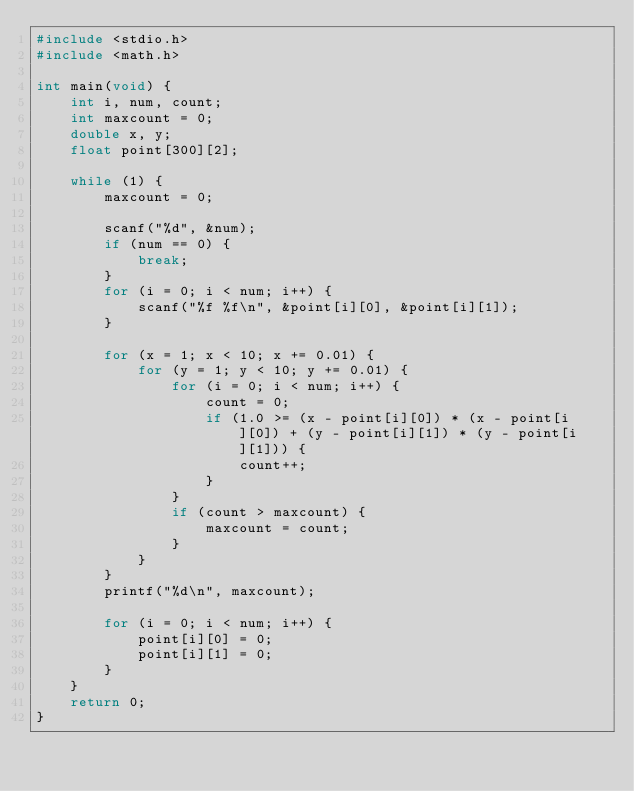Convert code to text. <code><loc_0><loc_0><loc_500><loc_500><_C_>#include <stdio.h>
#include <math.h>

int main(void) {
	int i, num, count;
	int maxcount = 0;
	double x, y;
	float point[300][2];

	while (1) {
		maxcount = 0;

		scanf("%d", &num);
		if (num == 0) {
			break;
		}
		for (i = 0; i < num; i++) {
			scanf("%f %f\n", &point[i][0], &point[i][1]);
		}

		for (x = 1; x < 10; x += 0.01) {
			for (y = 1; y < 10; y += 0.01) {
				for (i = 0; i < num; i++) {
					count = 0;
					if (1.0 >= (x - point[i][0]) * (x - point[i][0]) + (y - point[i][1]) * (y - point[i][1])) {
						count++;
					}
				}
				if (count > maxcount) {
					maxcount = count;
				}
			}
		}
		printf("%d\n", maxcount);

		for (i = 0; i < num; i++) {
			point[i][0] = 0;
			point[i][1] = 0;
		}
	}
	return 0;
}</code> 